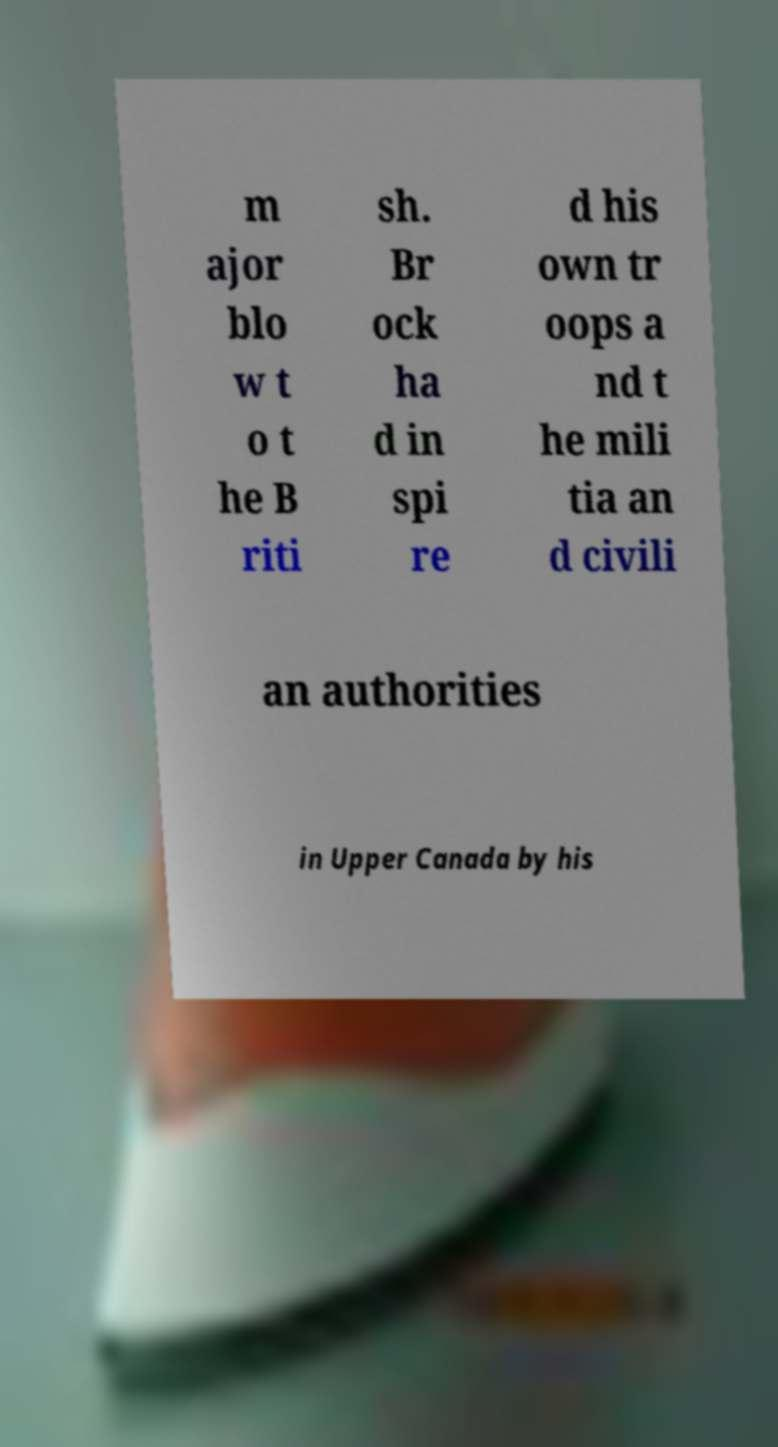There's text embedded in this image that I need extracted. Can you transcribe it verbatim? m ajor blo w t o t he B riti sh. Br ock ha d in spi re d his own tr oops a nd t he mili tia an d civili an authorities in Upper Canada by his 